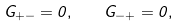Convert formula to latex. <formula><loc_0><loc_0><loc_500><loc_500>G _ { + - } = 0 , \quad G _ { - + } = 0 ,</formula> 